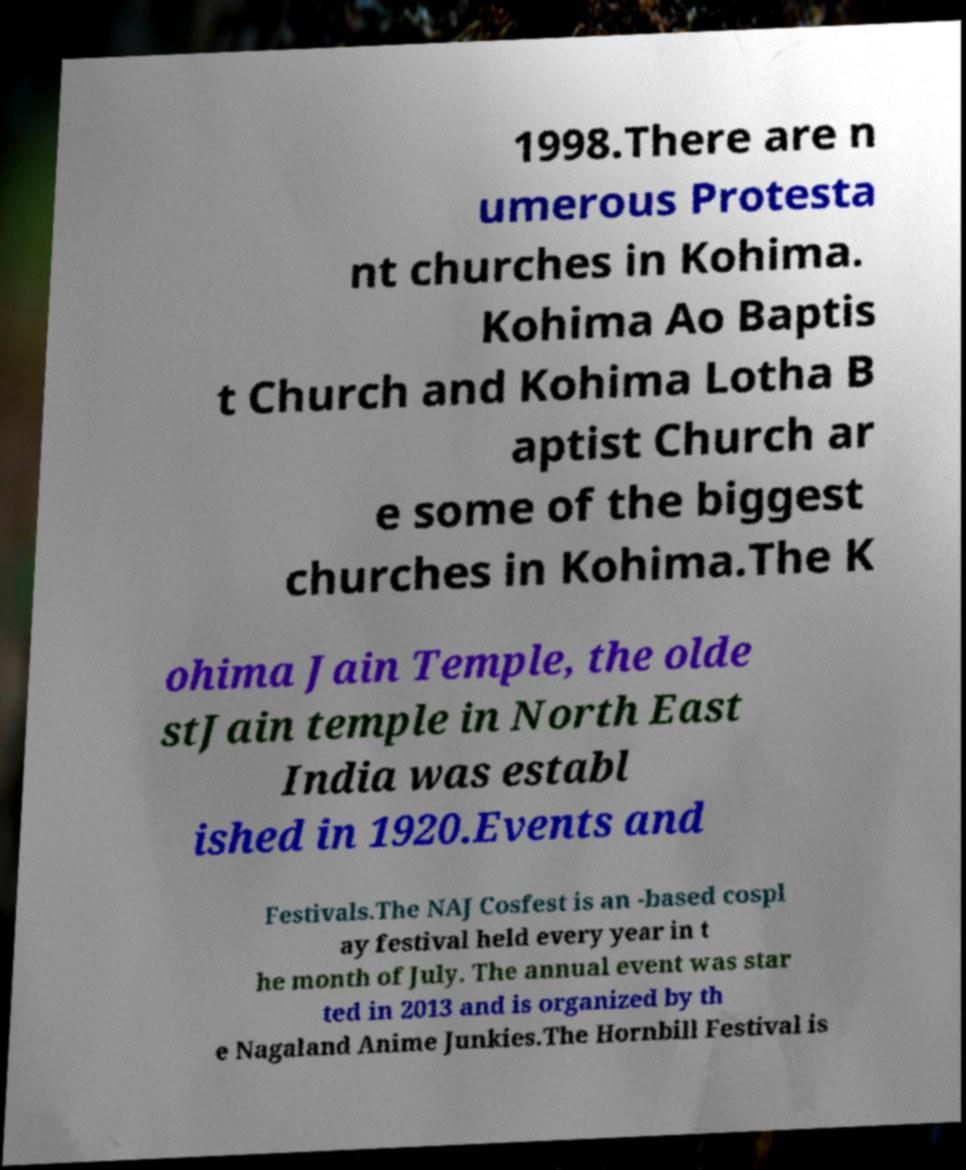What messages or text are displayed in this image? I need them in a readable, typed format. 1998.There are n umerous Protesta nt churches in Kohima. Kohima Ao Baptis t Church and Kohima Lotha B aptist Church ar e some of the biggest churches in Kohima.The K ohima Jain Temple, the olde stJain temple in North East India was establ ished in 1920.Events and Festivals.The NAJ Cosfest is an -based cospl ay festival held every year in t he month of July. The annual event was star ted in 2013 and is organized by th e Nagaland Anime Junkies.The Hornbill Festival is 